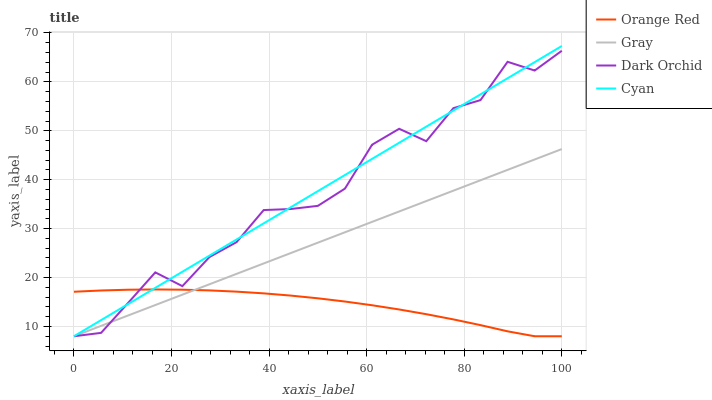Does Orange Red have the minimum area under the curve?
Answer yes or no. Yes. Does Cyan have the maximum area under the curve?
Answer yes or no. Yes. Does Dark Orchid have the minimum area under the curve?
Answer yes or no. No. Does Dark Orchid have the maximum area under the curve?
Answer yes or no. No. Is Gray the smoothest?
Answer yes or no. Yes. Is Dark Orchid the roughest?
Answer yes or no. Yes. Is Orange Red the smoothest?
Answer yes or no. No. Is Orange Red the roughest?
Answer yes or no. No. Does Cyan have the highest value?
Answer yes or no. Yes. Does Dark Orchid have the highest value?
Answer yes or no. No. Does Gray intersect Orange Red?
Answer yes or no. Yes. Is Gray less than Orange Red?
Answer yes or no. No. Is Gray greater than Orange Red?
Answer yes or no. No. 